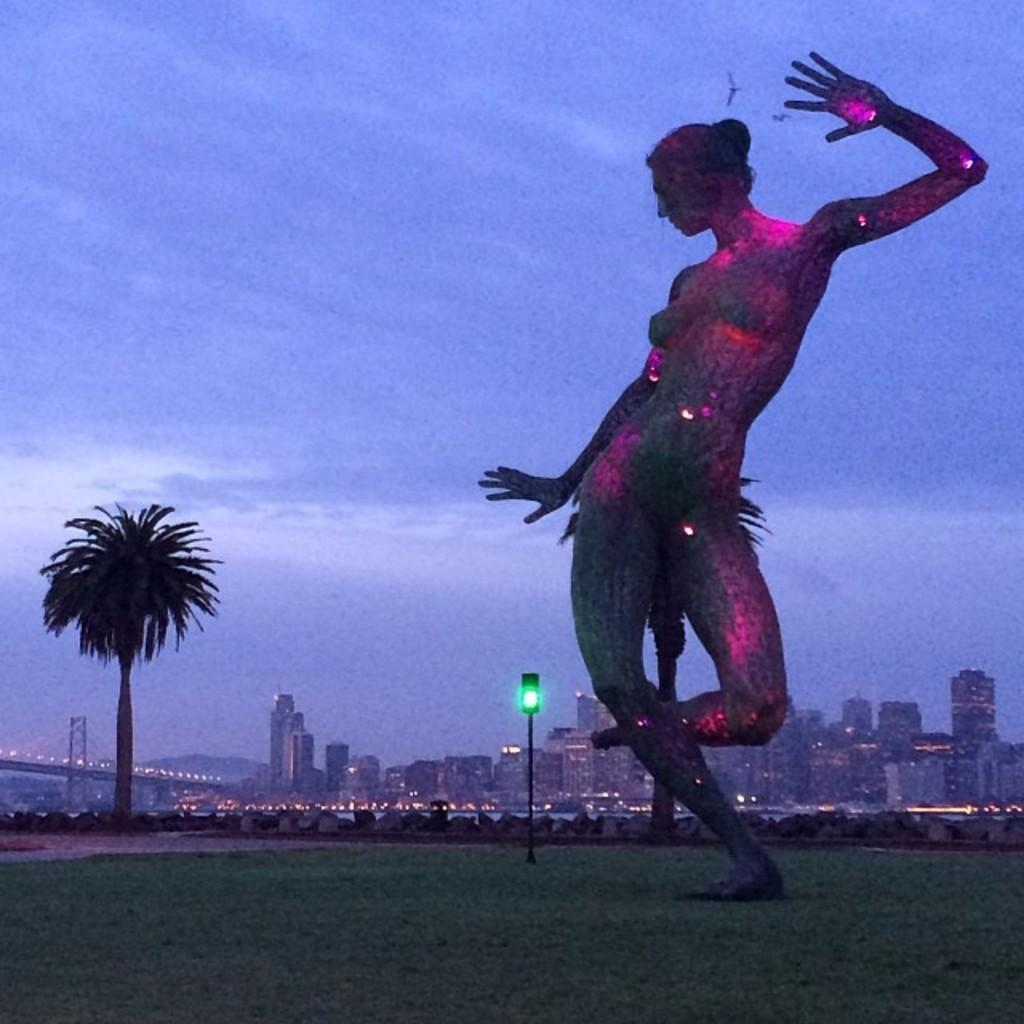What is there is a statue in the image, what is it standing on? The statue is on a grass surface. What can be seen behind the statue? There is a traffic light and a tree behind the statue. What is visible in the background of the image? There are buildings and a bridge in the background of the image. Reasoning: Let'g: Let's think step by step in order to produce the conversation. We start by identifying the main subject in the image, which is the statue. Then, we describe the surface it is standing on, which is grass. Next, we expand the conversation to include other objects and structures visible behind the statue, such as the traffic light and tree. Finally, we mention the background of the image, which includes buildings and a bridge. Absurd Question/Answer: What type of produce is being harvested from the jelly in the image? There is no produce or jelly present in the image; it features a statue on a grass surface with a traffic light and tree behind it. What is the person in the image holding? The person is holding a book in the image. What is the person sitting on? The person is sitting on a chair. What is located next to the chair? There is a table next to the chair. What is on the table? There is a lamp on the table. What can be seen in the background of the image? The background of the image is a bookshelf. Reasoning: Let's think step by step in order to produce the conversation. We start by identifying the main subject in the image, which is the person holding a book. Then, we describe the person's position, which is sitting on a chair. Next, we expand the conversation to include other objects and structures visible next to the chair, such as the table and lamp. Finally, we mention the background of the image, which is a bookshelf. Absurd Question/Answer: Q: 